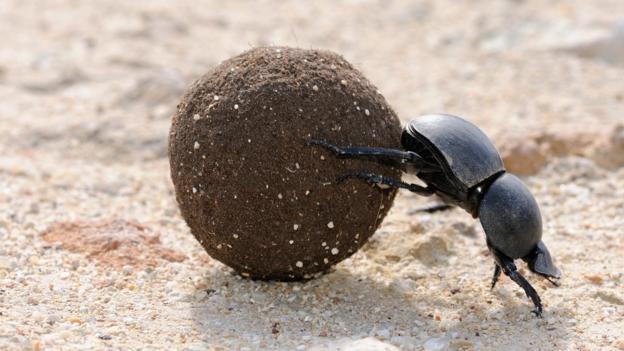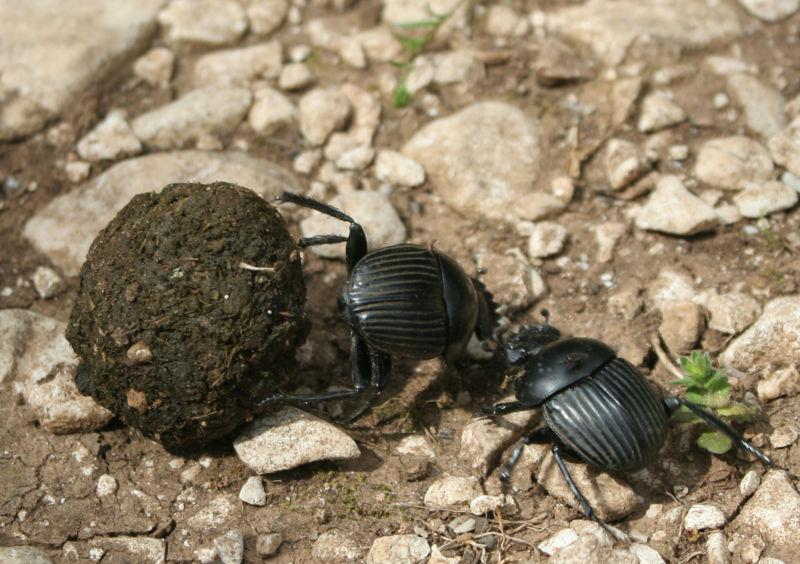The first image is the image on the left, the second image is the image on the right. Given the left and right images, does the statement "There are at least two insects in the image on the right." hold true? Answer yes or no. Yes. The first image is the image on the left, the second image is the image on the right. Given the left and right images, does the statement "An image shows more than one beetle by a shape made of dung." hold true? Answer yes or no. Yes. 